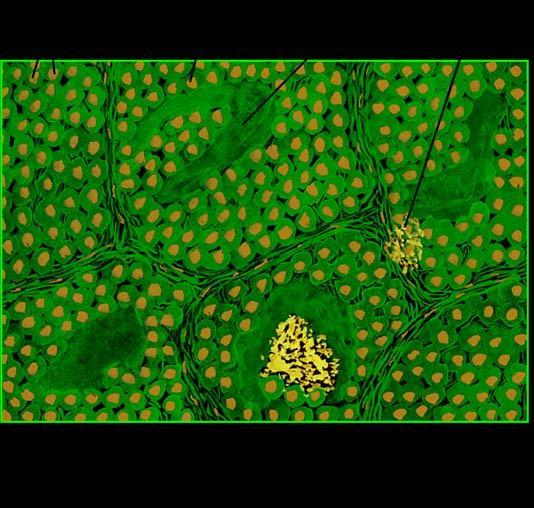does microscopy show organoid pattern of oval tumour cells and abundant amyloid stroma?
Answer the question using a single word or phrase. Yes 